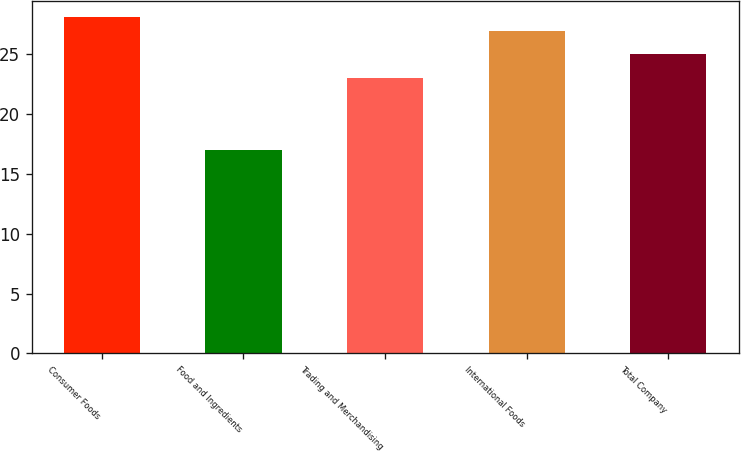Convert chart. <chart><loc_0><loc_0><loc_500><loc_500><bar_chart><fcel>Consumer Foods<fcel>Food and Ingredients<fcel>Trading and Merchandising<fcel>International Foods<fcel>Total Company<nl><fcel>28.1<fcel>17<fcel>23<fcel>27<fcel>25<nl></chart> 